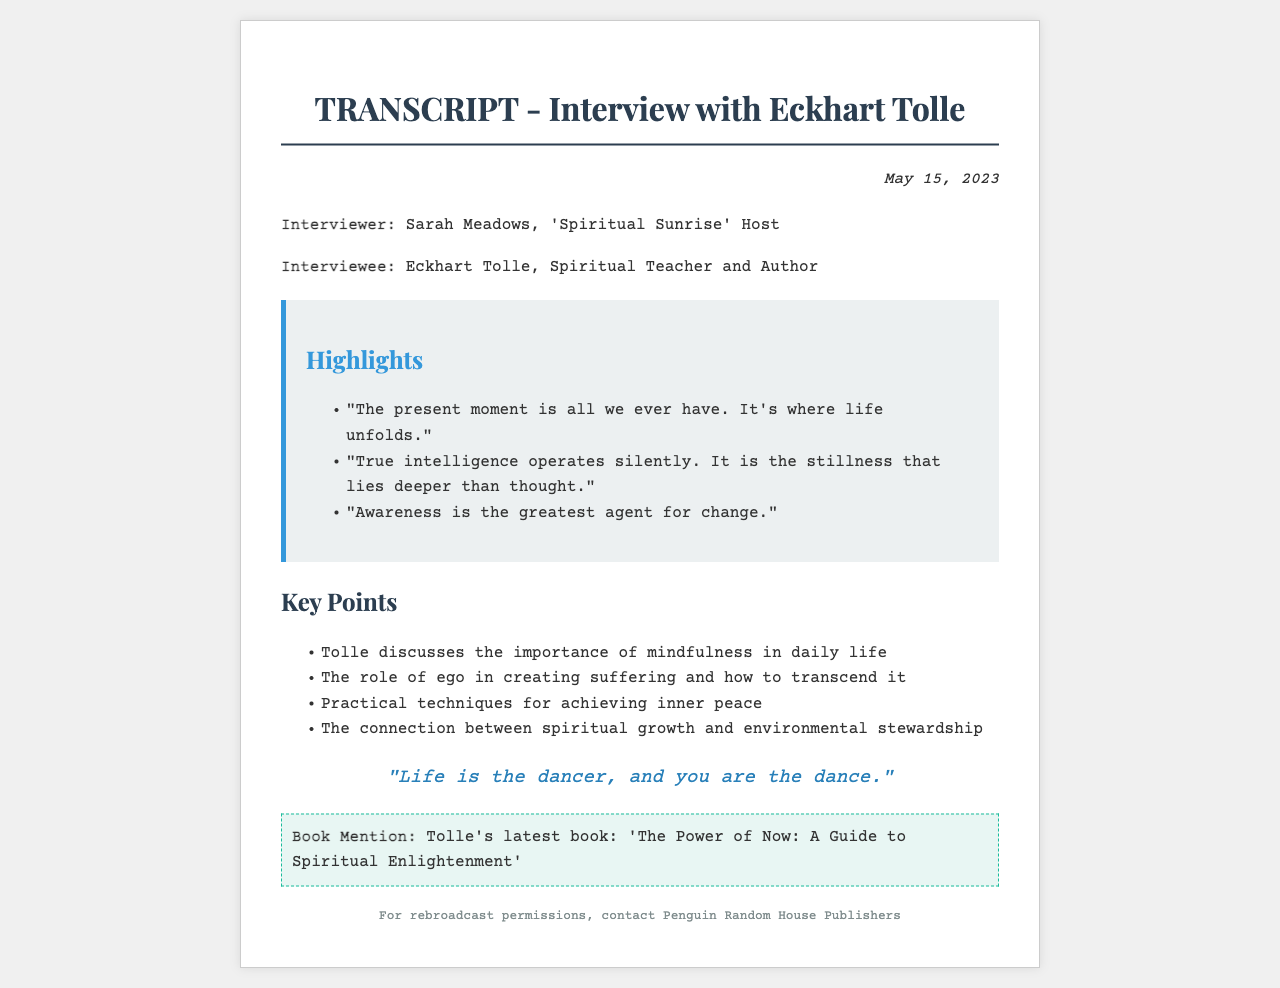What is the date of the interview? The date of the interview is mentioned at the top of the document.
Answer: May 15, 2023 Who is the interviewer in the transcript? The interviewer is listed under the participants section.
Answer: Sarah Meadows What is Eckhart Tolle's notable quote in the document? The notable quote is highlighted and stands out in its own section of the document.
Answer: "Life is the dancer, and you are the dance." What is the main subject of Tolle's latest book? The book mention states the title and subject of the book directly.
Answer: 'The Power of Now: A Guide to Spiritual Enlightenment' What does Tolle say about the present moment? One of the highlights directly quotes Tolle on the present moment.
Answer: "The present moment is all we ever have. It's where life unfolds." How many key points does the document list? The key points section lists specific points discussed in the interview, which can be counted.
Answer: Four What is indicated as the greatest agent for change? A highlight in the document addresses this specific concept directly.
Answer: Awareness Which aspect of spiritual growth does Tolle connect with environmental stewardship? This connection is mentioned in the key points section.
Answer: Spiritual growth 